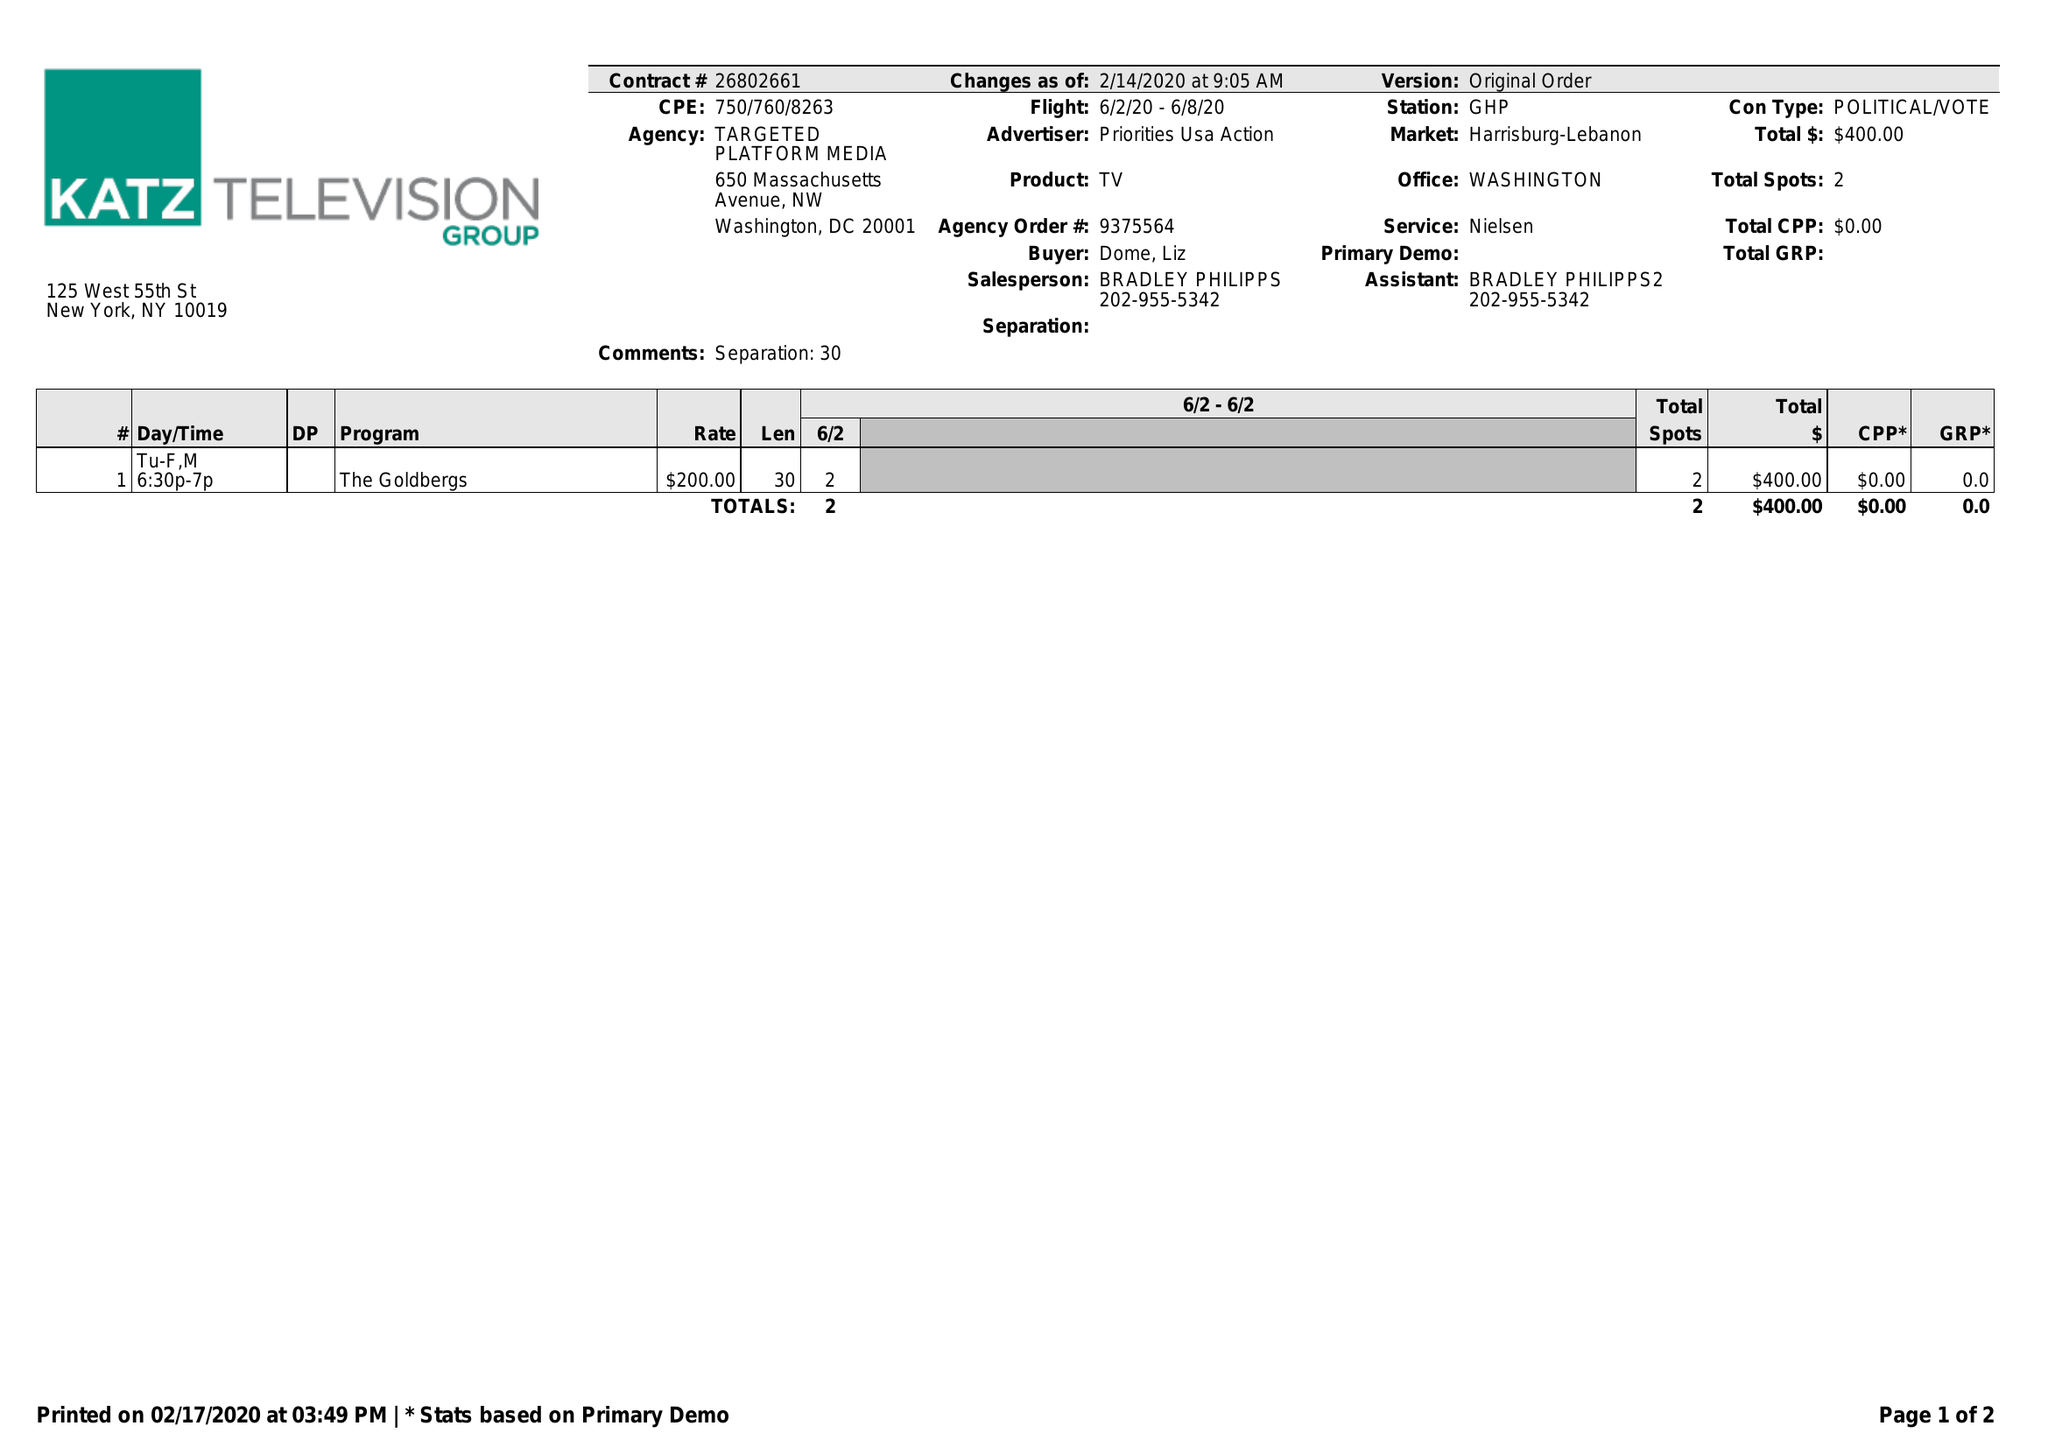What is the value for the advertiser?
Answer the question using a single word or phrase. PRIORITIES USA ACTION 